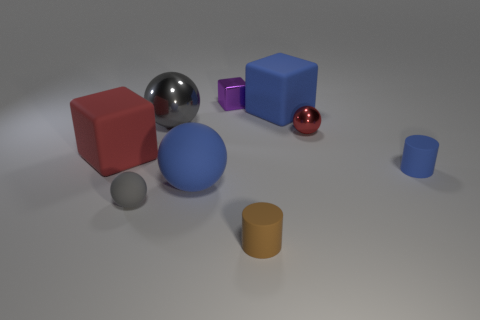Is the number of small brown things in front of the tiny gray matte sphere greater than the number of metallic cubes that are in front of the blue ball?
Make the answer very short. Yes. What shape is the large object that is the same material as the red sphere?
Offer a terse response. Sphere. How many other things are the same shape as the tiny gray matte object?
Your answer should be very brief. 3. The tiny shiny object that is on the left side of the tiny red thing has what shape?
Offer a very short reply. Cube. The large metallic object is what color?
Your response must be concise. Gray. How many other things are there of the same size as the purple shiny object?
Ensure brevity in your answer.  4. What is the material of the large cube that is behind the large gray object that is on the right side of the red rubber block?
Provide a short and direct response. Rubber. Do the red matte object and the blue thing that is behind the tiny blue rubber cylinder have the same size?
Offer a terse response. Yes. Is there a small metal sphere of the same color as the large metal object?
Your answer should be very brief. No. What number of big objects are either brown matte cubes or shiny spheres?
Offer a very short reply. 1. 